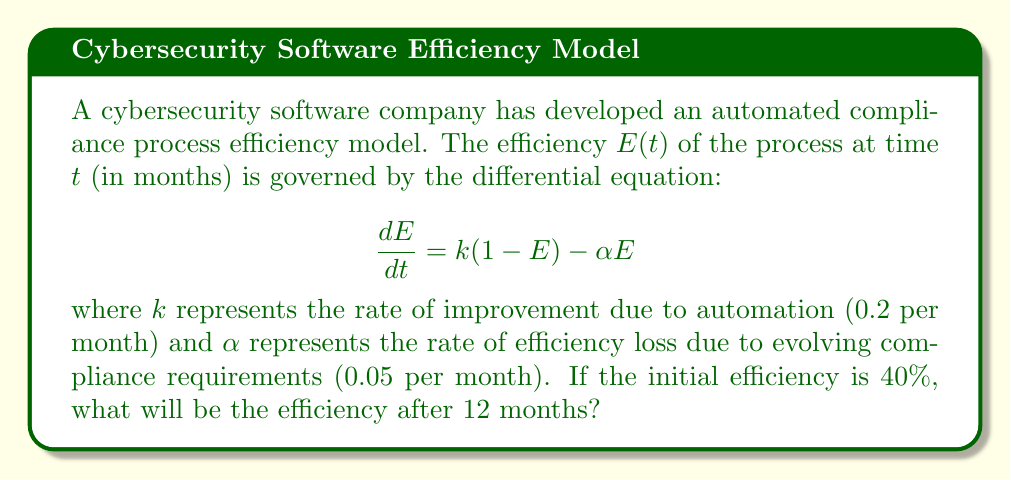Provide a solution to this math problem. To solve this problem, we'll follow these steps:

1) First, rearrange the differential equation:
   $$\frac{dE}{dt} = k(1-E) - \alpha E = k - kE - \alpha E = k - (k+\alpha)E$$

2) This is a first-order linear differential equation of the form:
   $$\frac{dE}{dt} + (k+\alpha)E = k$$

3) The general solution to this equation is:
   $$E(t) = \frac{k}{k+\alpha} + Ce^{-(k+\alpha)t}$$
   where $C$ is a constant determined by the initial condition.

4) Given values: $k=0.2$, $\alpha=0.05$, $E(0)=0.4$ (40% initial efficiency)

5) Substitute these values:
   $$E(t) = \frac{0.2}{0.2+0.05} + Ce^{-(0.2+0.05)t} = 0.8 + Ce^{-0.25t}$$

6) Use the initial condition $E(0)=0.4$ to find $C$:
   $$0.4 = 0.8 + C$$
   $$C = -0.4$$

7) The particular solution is:
   $$E(t) = 0.8 - 0.4e^{-0.25t}$$

8) To find efficiency after 12 months, calculate $E(12)$:
   $$E(12) = 0.8 - 0.4e^{-0.25(12)} = 0.8 - 0.4e^{-3} \approx 0.7560$$

9) Convert to percentage: 0.7560 * 100% ≈ 75.60%
Answer: 75.60% 